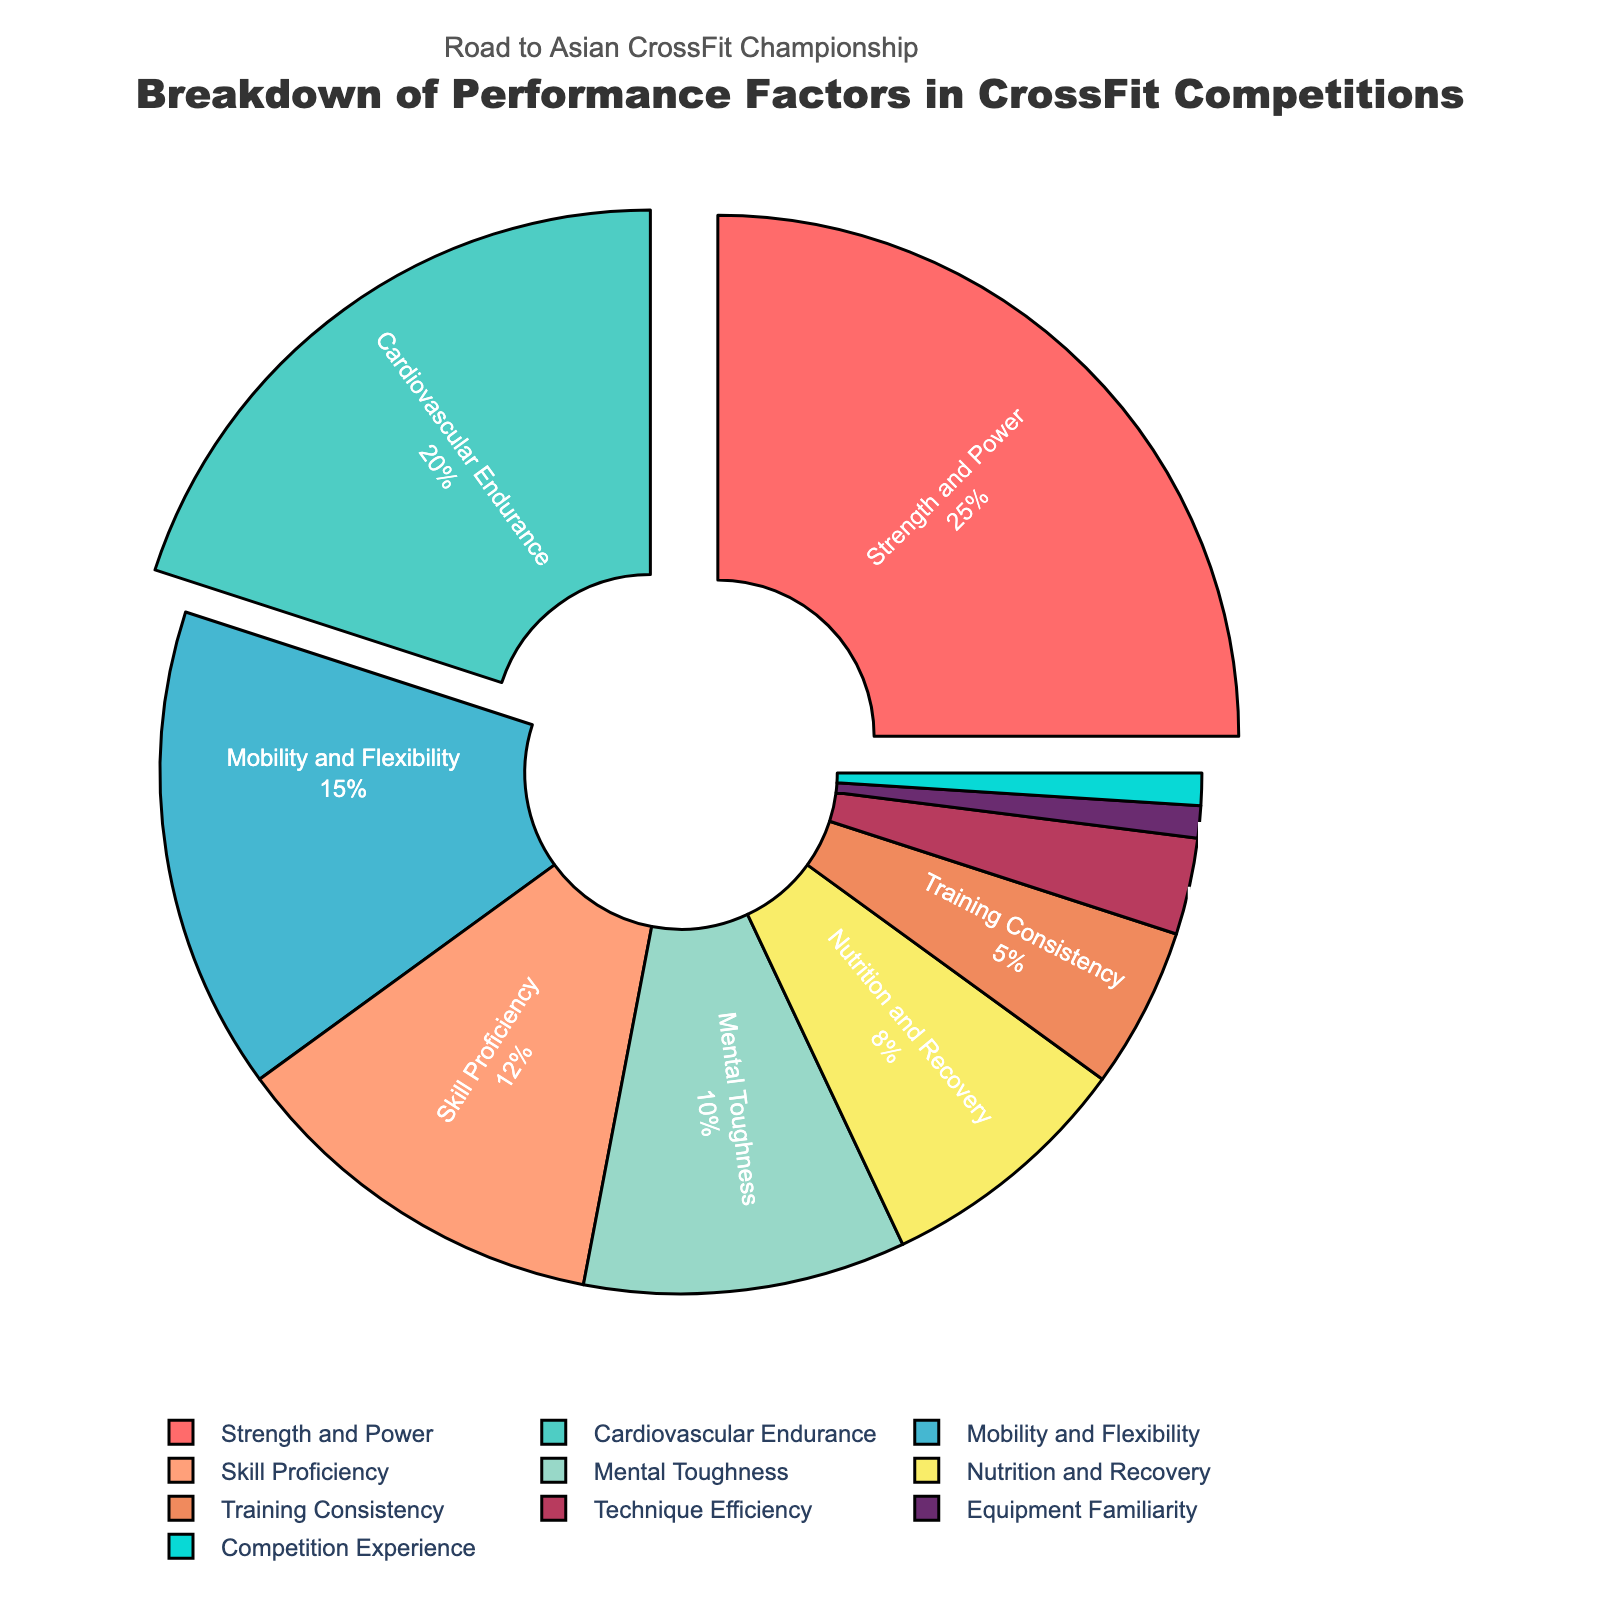What are the top three performance factors by percentage in the pie chart? The top three performance factors by percentage are those with the largest slices in the pie chart: Strength and Power (25%), Cardiovascular Endurance (20%), and Mobility and Flexibility (15%).
Answer: Strength and Power, Cardiovascular Endurance, Mobility and Flexibility What is the combined percentage of the three lowest performance factors? The three lowest performance factors are Technique Efficiency (3%), Equipment Familiarity (1%), and Competition Experience (1%). Adding these percentages gives 3% + 1% + 1% = 5%.
Answer: 5% How much greater is the percentage for Strength and Power compared to Skill Proficiency? The percentage for Strength and Power is 25%, while Skill Proficiency is 12%. The difference is 25% - 12% = 13%.
Answer: 13% Which performance factor has a light blue color in the pie chart? The light blue color in the pie chart corresponds to Cardiovascular Endurance.
Answer: Cardiovascular Endurance What is the difference between the combined percentage of Strength and Power and Cardiovascular Endurance compared to the combined percentage of Nutrition and Recovery and Training Consistency? The combined percentage of Strength and Power and Cardiovascular Endurance is 25% + 20% = 45%. The combined percentage of Nutrition and Recovery and Training Consistency is 8% + 5% = 13%. The difference is 45% - 13% = 32%.
Answer: 32% By what factor is Mobility and Flexibility greater than Technique Efficiency? Mobility and Flexibility is 15%, and Technique Efficiency is 3%. The factor is calculated as 15% / 3% = 5.
Answer: 5 Which performance factor accounts for 10% of the total? The performance factor that accounts for 10% of the total is Mental Toughness.
Answer: Mental Toughness What is the sum of the percentages for all performance factors represented by the pie chart? The sum of the percentages is the total of all the slices in the pie chart, which should equal 100% as it represents the whole dataset.
Answer: 100% How does the percentage for Mobility and Flexibility compare to the total percentage of Nutrition and Recovery and Training Consistency combined? Mobility and Flexibility is 15%, while the combined percentage of Nutrition and Recovery and Training Consistency is 8% + 5% = 13%. Mobility and Flexibility (15%) is 2% higher than the combined percentage.
Answer: 2% Which two performance factors have the smallest representation in the pie chart? The two performance factors with the smallest representation in the pie chart are Equipment Familiarity and Competition Experience, each with 1%.
Answer: Equipment Familiarity, Competition Experience 